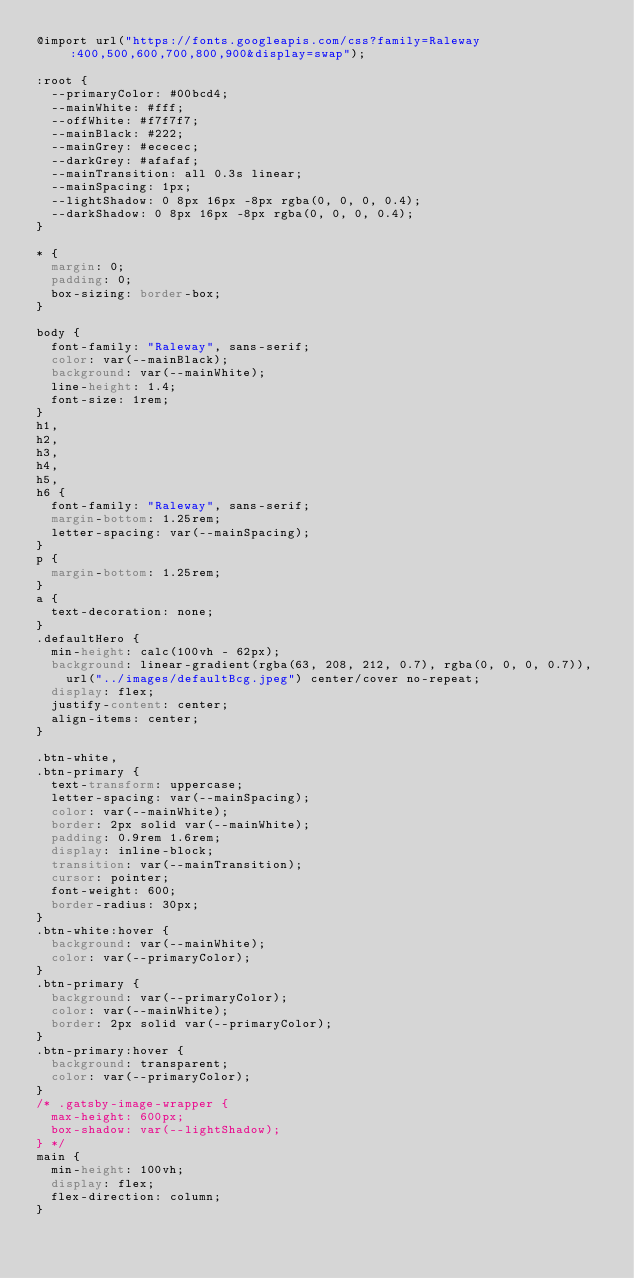Convert code to text. <code><loc_0><loc_0><loc_500><loc_500><_CSS_>@import url("https://fonts.googleapis.com/css?family=Raleway:400,500,600,700,800,900&display=swap");

:root {
  --primaryColor: #00bcd4;
  --mainWhite: #fff;
  --offWhite: #f7f7f7;
  --mainBlack: #222;
  --mainGrey: #ececec;
  --darkGrey: #afafaf;
  --mainTransition: all 0.3s linear;
  --mainSpacing: 1px;
  --lightShadow: 0 8px 16px -8px rgba(0, 0, 0, 0.4);
  --darkShadow: 0 8px 16px -8px rgba(0, 0, 0, 0.4);
}

* {
  margin: 0;
  padding: 0;
  box-sizing: border-box;
}

body {
  font-family: "Raleway", sans-serif;
  color: var(--mainBlack);
  background: var(--mainWhite);
  line-height: 1.4;
  font-size: 1rem;
}
h1,
h2,
h3,
h4,
h5,
h6 {
  font-family: "Raleway", sans-serif;
  margin-bottom: 1.25rem;
  letter-spacing: var(--mainSpacing);
}
p {
  margin-bottom: 1.25rem;
}
a {
  text-decoration: none;
}
.defaultHero {
  min-height: calc(100vh - 62px);
  background: linear-gradient(rgba(63, 208, 212, 0.7), rgba(0, 0, 0, 0.7)),
    url("../images/defaultBcg.jpeg") center/cover no-repeat;
  display: flex;
  justify-content: center;
  align-items: center;
}

.btn-white,
.btn-primary {
  text-transform: uppercase;
  letter-spacing: var(--mainSpacing);
  color: var(--mainWhite);
  border: 2px solid var(--mainWhite);
  padding: 0.9rem 1.6rem;
  display: inline-block;
  transition: var(--mainTransition);
  cursor: pointer;
  font-weight: 600;
  border-radius: 30px;
}
.btn-white:hover {
  background: var(--mainWhite);
  color: var(--primaryColor);
}
.btn-primary {
  background: var(--primaryColor);
  color: var(--mainWhite);
  border: 2px solid var(--primaryColor);
}
.btn-primary:hover {
  background: transparent;
  color: var(--primaryColor);
}
/* .gatsby-image-wrapper {
  max-height: 600px;
  box-shadow: var(--lightShadow);
} */
main {
  min-height: 100vh;
  display: flex;
  flex-direction: column;
}
</code> 